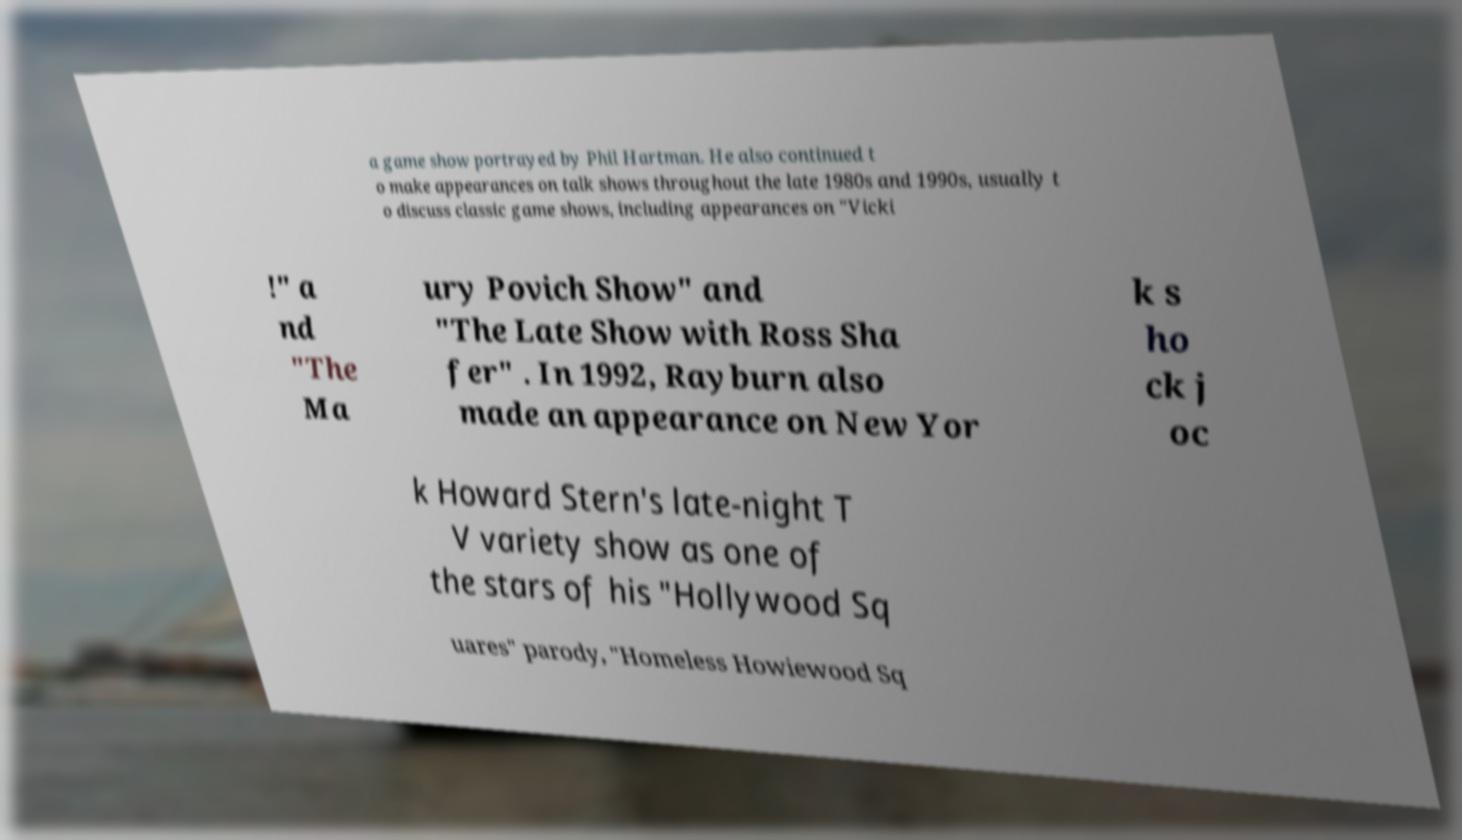For documentation purposes, I need the text within this image transcribed. Could you provide that? a game show portrayed by Phil Hartman. He also continued t o make appearances on talk shows throughout the late 1980s and 1990s, usually t o discuss classic game shows, including appearances on "Vicki !" a nd "The Ma ury Povich Show" and "The Late Show with Ross Sha fer" . In 1992, Rayburn also made an appearance on New Yor k s ho ck j oc k Howard Stern's late-night T V variety show as one of the stars of his "Hollywood Sq uares" parody, "Homeless Howiewood Sq 